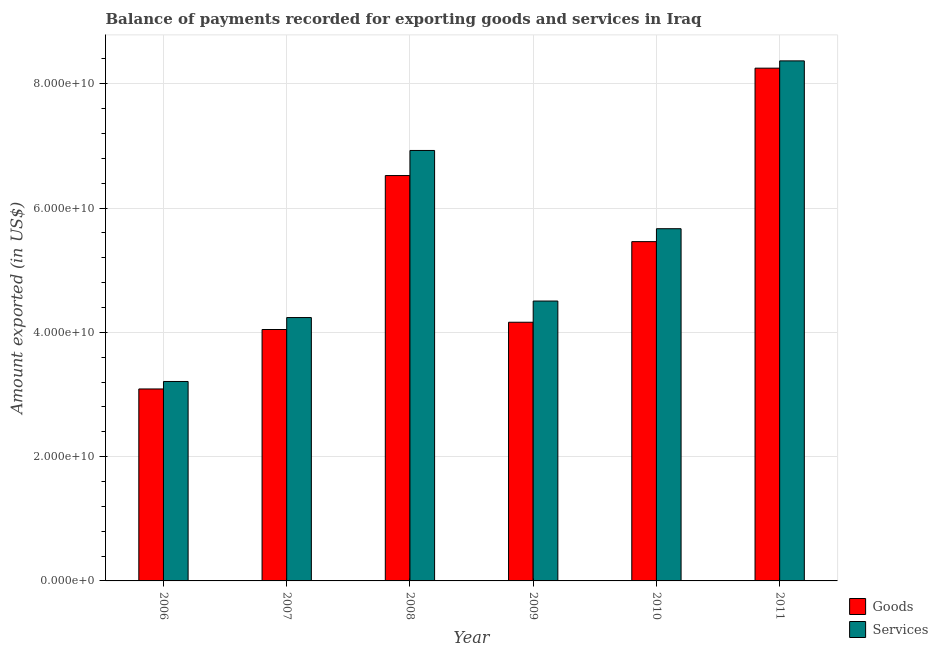How many different coloured bars are there?
Ensure brevity in your answer.  2. Are the number of bars per tick equal to the number of legend labels?
Provide a short and direct response. Yes. How many bars are there on the 6th tick from the left?
Your answer should be very brief. 2. How many bars are there on the 5th tick from the right?
Your response must be concise. 2. In how many cases, is the number of bars for a given year not equal to the number of legend labels?
Ensure brevity in your answer.  0. What is the amount of goods exported in 2010?
Offer a terse response. 5.46e+1. Across all years, what is the maximum amount of services exported?
Provide a short and direct response. 8.37e+1. Across all years, what is the minimum amount of goods exported?
Your answer should be very brief. 3.09e+1. In which year was the amount of services exported maximum?
Make the answer very short. 2011. What is the total amount of goods exported in the graph?
Offer a terse response. 3.15e+11. What is the difference between the amount of services exported in 2008 and that in 2009?
Give a very brief answer. 2.42e+1. What is the difference between the amount of goods exported in 2006 and the amount of services exported in 2010?
Give a very brief answer. -2.37e+1. What is the average amount of services exported per year?
Give a very brief answer. 5.49e+1. In the year 2011, what is the difference between the amount of services exported and amount of goods exported?
Ensure brevity in your answer.  0. In how many years, is the amount of services exported greater than 60000000000 US$?
Give a very brief answer. 2. What is the ratio of the amount of goods exported in 2006 to that in 2008?
Provide a short and direct response. 0.47. Is the amount of services exported in 2006 less than that in 2009?
Give a very brief answer. Yes. Is the difference between the amount of goods exported in 2006 and 2011 greater than the difference between the amount of services exported in 2006 and 2011?
Provide a succinct answer. No. What is the difference between the highest and the second highest amount of goods exported?
Your answer should be very brief. 1.73e+1. What is the difference between the highest and the lowest amount of services exported?
Make the answer very short. 5.16e+1. In how many years, is the amount of services exported greater than the average amount of services exported taken over all years?
Your answer should be compact. 3. What does the 2nd bar from the left in 2011 represents?
Make the answer very short. Services. What does the 2nd bar from the right in 2008 represents?
Give a very brief answer. Goods. How many years are there in the graph?
Give a very brief answer. 6. Does the graph contain any zero values?
Offer a terse response. No. Does the graph contain grids?
Offer a very short reply. Yes. Where does the legend appear in the graph?
Provide a short and direct response. Bottom right. What is the title of the graph?
Offer a very short reply. Balance of payments recorded for exporting goods and services in Iraq. What is the label or title of the X-axis?
Keep it short and to the point. Year. What is the label or title of the Y-axis?
Ensure brevity in your answer.  Amount exported (in US$). What is the Amount exported (in US$) in Goods in 2006?
Provide a short and direct response. 3.09e+1. What is the Amount exported (in US$) of Services in 2006?
Give a very brief answer. 3.21e+1. What is the Amount exported (in US$) in Goods in 2007?
Keep it short and to the point. 4.05e+1. What is the Amount exported (in US$) in Services in 2007?
Your response must be concise. 4.24e+1. What is the Amount exported (in US$) of Goods in 2008?
Give a very brief answer. 6.52e+1. What is the Amount exported (in US$) of Services in 2008?
Your response must be concise. 6.93e+1. What is the Amount exported (in US$) in Goods in 2009?
Ensure brevity in your answer.  4.16e+1. What is the Amount exported (in US$) of Services in 2009?
Provide a succinct answer. 4.50e+1. What is the Amount exported (in US$) of Goods in 2010?
Provide a succinct answer. 5.46e+1. What is the Amount exported (in US$) in Services in 2010?
Keep it short and to the point. 5.67e+1. What is the Amount exported (in US$) in Goods in 2011?
Provide a short and direct response. 8.25e+1. What is the Amount exported (in US$) of Services in 2011?
Your response must be concise. 8.37e+1. Across all years, what is the maximum Amount exported (in US$) of Goods?
Offer a very short reply. 8.25e+1. Across all years, what is the maximum Amount exported (in US$) in Services?
Give a very brief answer. 8.37e+1. Across all years, what is the minimum Amount exported (in US$) in Goods?
Your answer should be very brief. 3.09e+1. Across all years, what is the minimum Amount exported (in US$) of Services?
Offer a terse response. 3.21e+1. What is the total Amount exported (in US$) in Goods in the graph?
Offer a terse response. 3.15e+11. What is the total Amount exported (in US$) of Services in the graph?
Ensure brevity in your answer.  3.29e+11. What is the difference between the Amount exported (in US$) in Goods in 2006 and that in 2007?
Offer a terse response. -9.57e+09. What is the difference between the Amount exported (in US$) of Services in 2006 and that in 2007?
Make the answer very short. -1.03e+1. What is the difference between the Amount exported (in US$) of Goods in 2006 and that in 2008?
Provide a succinct answer. -3.43e+1. What is the difference between the Amount exported (in US$) in Services in 2006 and that in 2008?
Make the answer very short. -3.72e+1. What is the difference between the Amount exported (in US$) of Goods in 2006 and that in 2009?
Provide a short and direct response. -1.07e+1. What is the difference between the Amount exported (in US$) of Services in 2006 and that in 2009?
Provide a short and direct response. -1.29e+1. What is the difference between the Amount exported (in US$) in Goods in 2006 and that in 2010?
Keep it short and to the point. -2.37e+1. What is the difference between the Amount exported (in US$) of Services in 2006 and that in 2010?
Provide a short and direct response. -2.46e+1. What is the difference between the Amount exported (in US$) in Goods in 2006 and that in 2011?
Ensure brevity in your answer.  -5.16e+1. What is the difference between the Amount exported (in US$) in Services in 2006 and that in 2011?
Provide a succinct answer. -5.16e+1. What is the difference between the Amount exported (in US$) of Goods in 2007 and that in 2008?
Offer a very short reply. -2.48e+1. What is the difference between the Amount exported (in US$) of Services in 2007 and that in 2008?
Offer a terse response. -2.69e+1. What is the difference between the Amount exported (in US$) in Goods in 2007 and that in 2009?
Make the answer very short. -1.17e+09. What is the difference between the Amount exported (in US$) of Services in 2007 and that in 2009?
Your answer should be compact. -2.66e+09. What is the difference between the Amount exported (in US$) of Goods in 2007 and that in 2010?
Ensure brevity in your answer.  -1.41e+1. What is the difference between the Amount exported (in US$) in Services in 2007 and that in 2010?
Offer a very short reply. -1.43e+1. What is the difference between the Amount exported (in US$) in Goods in 2007 and that in 2011?
Your answer should be very brief. -4.21e+1. What is the difference between the Amount exported (in US$) in Services in 2007 and that in 2011?
Offer a terse response. -4.13e+1. What is the difference between the Amount exported (in US$) in Goods in 2008 and that in 2009?
Offer a very short reply. 2.36e+1. What is the difference between the Amount exported (in US$) of Services in 2008 and that in 2009?
Your response must be concise. 2.42e+1. What is the difference between the Amount exported (in US$) in Goods in 2008 and that in 2010?
Your response must be concise. 1.06e+1. What is the difference between the Amount exported (in US$) in Services in 2008 and that in 2010?
Your response must be concise. 1.26e+1. What is the difference between the Amount exported (in US$) of Goods in 2008 and that in 2011?
Your answer should be compact. -1.73e+1. What is the difference between the Amount exported (in US$) of Services in 2008 and that in 2011?
Offer a terse response. -1.44e+1. What is the difference between the Amount exported (in US$) in Goods in 2009 and that in 2010?
Offer a very short reply. -1.30e+1. What is the difference between the Amount exported (in US$) of Services in 2009 and that in 2010?
Keep it short and to the point. -1.16e+1. What is the difference between the Amount exported (in US$) of Goods in 2009 and that in 2011?
Provide a short and direct response. -4.09e+1. What is the difference between the Amount exported (in US$) in Services in 2009 and that in 2011?
Offer a very short reply. -3.86e+1. What is the difference between the Amount exported (in US$) in Goods in 2010 and that in 2011?
Provide a short and direct response. -2.79e+1. What is the difference between the Amount exported (in US$) in Services in 2010 and that in 2011?
Provide a short and direct response. -2.70e+1. What is the difference between the Amount exported (in US$) in Goods in 2006 and the Amount exported (in US$) in Services in 2007?
Keep it short and to the point. -1.15e+1. What is the difference between the Amount exported (in US$) of Goods in 2006 and the Amount exported (in US$) of Services in 2008?
Your response must be concise. -3.84e+1. What is the difference between the Amount exported (in US$) of Goods in 2006 and the Amount exported (in US$) of Services in 2009?
Provide a succinct answer. -1.41e+1. What is the difference between the Amount exported (in US$) in Goods in 2006 and the Amount exported (in US$) in Services in 2010?
Make the answer very short. -2.58e+1. What is the difference between the Amount exported (in US$) of Goods in 2006 and the Amount exported (in US$) of Services in 2011?
Offer a very short reply. -5.28e+1. What is the difference between the Amount exported (in US$) in Goods in 2007 and the Amount exported (in US$) in Services in 2008?
Offer a very short reply. -2.88e+1. What is the difference between the Amount exported (in US$) in Goods in 2007 and the Amount exported (in US$) in Services in 2009?
Give a very brief answer. -4.58e+09. What is the difference between the Amount exported (in US$) of Goods in 2007 and the Amount exported (in US$) of Services in 2010?
Your response must be concise. -1.62e+1. What is the difference between the Amount exported (in US$) of Goods in 2007 and the Amount exported (in US$) of Services in 2011?
Offer a very short reply. -4.32e+1. What is the difference between the Amount exported (in US$) in Goods in 2008 and the Amount exported (in US$) in Services in 2009?
Make the answer very short. 2.02e+1. What is the difference between the Amount exported (in US$) in Goods in 2008 and the Amount exported (in US$) in Services in 2010?
Ensure brevity in your answer.  8.55e+09. What is the difference between the Amount exported (in US$) of Goods in 2008 and the Amount exported (in US$) of Services in 2011?
Provide a succinct answer. -1.85e+1. What is the difference between the Amount exported (in US$) of Goods in 2009 and the Amount exported (in US$) of Services in 2010?
Provide a succinct answer. -1.51e+1. What is the difference between the Amount exported (in US$) in Goods in 2009 and the Amount exported (in US$) in Services in 2011?
Keep it short and to the point. -4.21e+1. What is the difference between the Amount exported (in US$) of Goods in 2010 and the Amount exported (in US$) of Services in 2011?
Offer a very short reply. -2.91e+1. What is the average Amount exported (in US$) of Goods per year?
Give a very brief answer. 5.25e+1. What is the average Amount exported (in US$) in Services per year?
Give a very brief answer. 5.49e+1. In the year 2006, what is the difference between the Amount exported (in US$) in Goods and Amount exported (in US$) in Services?
Give a very brief answer. -1.21e+09. In the year 2007, what is the difference between the Amount exported (in US$) in Goods and Amount exported (in US$) in Services?
Ensure brevity in your answer.  -1.92e+09. In the year 2008, what is the difference between the Amount exported (in US$) of Goods and Amount exported (in US$) of Services?
Offer a very short reply. -4.04e+09. In the year 2009, what is the difference between the Amount exported (in US$) of Goods and Amount exported (in US$) of Services?
Your response must be concise. -3.41e+09. In the year 2010, what is the difference between the Amount exported (in US$) of Goods and Amount exported (in US$) of Services?
Your answer should be compact. -2.08e+09. In the year 2011, what is the difference between the Amount exported (in US$) of Goods and Amount exported (in US$) of Services?
Provide a succinct answer. -1.17e+09. What is the ratio of the Amount exported (in US$) of Goods in 2006 to that in 2007?
Provide a short and direct response. 0.76. What is the ratio of the Amount exported (in US$) of Services in 2006 to that in 2007?
Your answer should be very brief. 0.76. What is the ratio of the Amount exported (in US$) in Goods in 2006 to that in 2008?
Your response must be concise. 0.47. What is the ratio of the Amount exported (in US$) in Services in 2006 to that in 2008?
Keep it short and to the point. 0.46. What is the ratio of the Amount exported (in US$) of Goods in 2006 to that in 2009?
Ensure brevity in your answer.  0.74. What is the ratio of the Amount exported (in US$) in Services in 2006 to that in 2009?
Provide a short and direct response. 0.71. What is the ratio of the Amount exported (in US$) in Goods in 2006 to that in 2010?
Your answer should be compact. 0.57. What is the ratio of the Amount exported (in US$) of Services in 2006 to that in 2010?
Give a very brief answer. 0.57. What is the ratio of the Amount exported (in US$) of Goods in 2006 to that in 2011?
Your response must be concise. 0.37. What is the ratio of the Amount exported (in US$) of Services in 2006 to that in 2011?
Keep it short and to the point. 0.38. What is the ratio of the Amount exported (in US$) in Goods in 2007 to that in 2008?
Give a very brief answer. 0.62. What is the ratio of the Amount exported (in US$) of Services in 2007 to that in 2008?
Offer a very short reply. 0.61. What is the ratio of the Amount exported (in US$) of Goods in 2007 to that in 2009?
Ensure brevity in your answer.  0.97. What is the ratio of the Amount exported (in US$) in Services in 2007 to that in 2009?
Offer a terse response. 0.94. What is the ratio of the Amount exported (in US$) of Goods in 2007 to that in 2010?
Offer a terse response. 0.74. What is the ratio of the Amount exported (in US$) of Services in 2007 to that in 2010?
Your answer should be very brief. 0.75. What is the ratio of the Amount exported (in US$) in Goods in 2007 to that in 2011?
Provide a short and direct response. 0.49. What is the ratio of the Amount exported (in US$) in Services in 2007 to that in 2011?
Offer a terse response. 0.51. What is the ratio of the Amount exported (in US$) in Goods in 2008 to that in 2009?
Ensure brevity in your answer.  1.57. What is the ratio of the Amount exported (in US$) in Services in 2008 to that in 2009?
Your response must be concise. 1.54. What is the ratio of the Amount exported (in US$) in Goods in 2008 to that in 2010?
Your answer should be compact. 1.19. What is the ratio of the Amount exported (in US$) of Services in 2008 to that in 2010?
Your answer should be very brief. 1.22. What is the ratio of the Amount exported (in US$) of Goods in 2008 to that in 2011?
Offer a terse response. 0.79. What is the ratio of the Amount exported (in US$) in Services in 2008 to that in 2011?
Give a very brief answer. 0.83. What is the ratio of the Amount exported (in US$) in Goods in 2009 to that in 2010?
Ensure brevity in your answer.  0.76. What is the ratio of the Amount exported (in US$) of Services in 2009 to that in 2010?
Offer a very short reply. 0.79. What is the ratio of the Amount exported (in US$) of Goods in 2009 to that in 2011?
Keep it short and to the point. 0.5. What is the ratio of the Amount exported (in US$) in Services in 2009 to that in 2011?
Your answer should be very brief. 0.54. What is the ratio of the Amount exported (in US$) of Goods in 2010 to that in 2011?
Keep it short and to the point. 0.66. What is the ratio of the Amount exported (in US$) in Services in 2010 to that in 2011?
Offer a very short reply. 0.68. What is the difference between the highest and the second highest Amount exported (in US$) of Goods?
Your answer should be compact. 1.73e+1. What is the difference between the highest and the second highest Amount exported (in US$) in Services?
Make the answer very short. 1.44e+1. What is the difference between the highest and the lowest Amount exported (in US$) of Goods?
Keep it short and to the point. 5.16e+1. What is the difference between the highest and the lowest Amount exported (in US$) of Services?
Ensure brevity in your answer.  5.16e+1. 